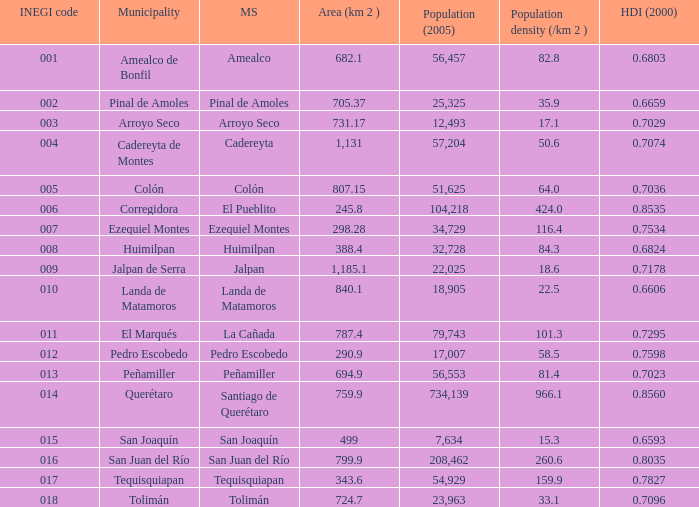WHich INEGI code has a Population density (/km 2 ) smaller than 81.4 and 0.6593 Human Development Index (2000)? 15.0. 